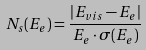Convert formula to latex. <formula><loc_0><loc_0><loc_500><loc_500>N _ { s } ( E _ { e } ) = \frac { | E _ { v i s } - E _ { e } | } { E _ { e } \cdot \sigma ( E _ { e } ) }</formula> 